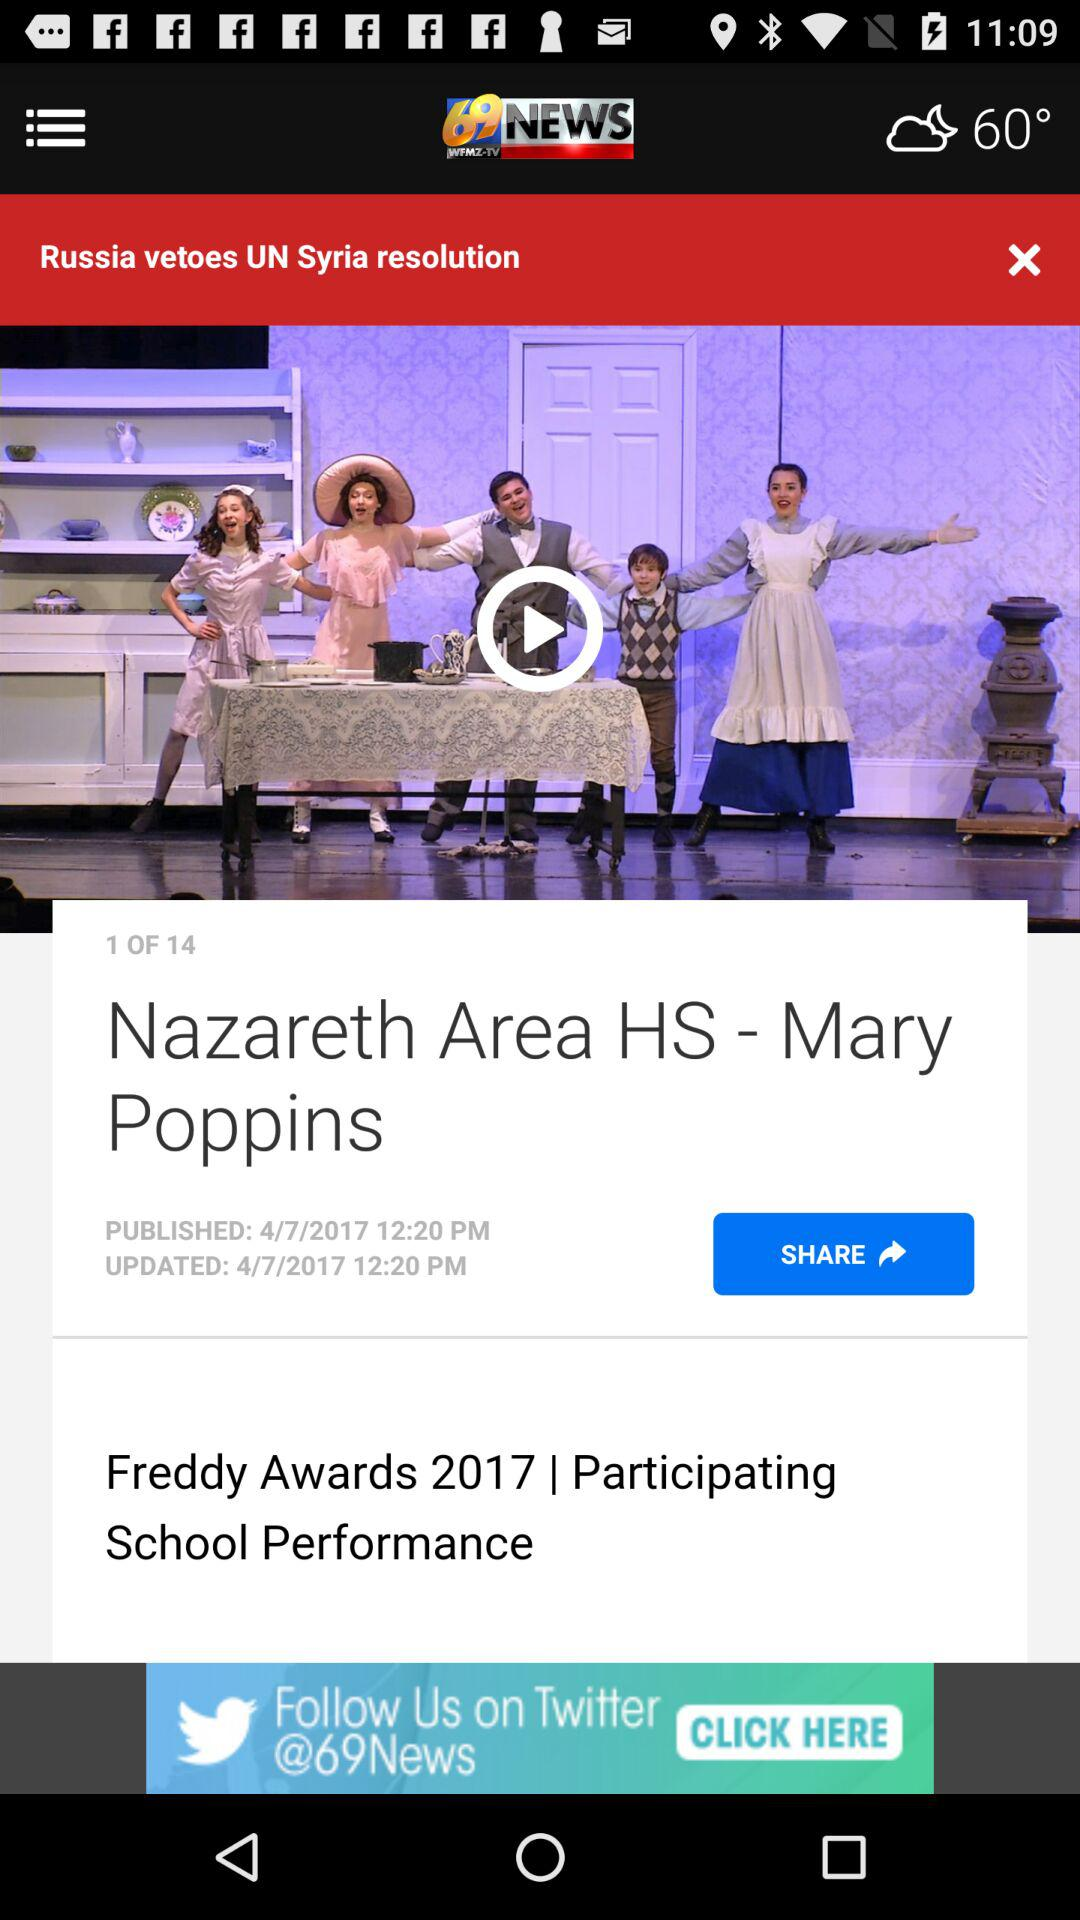What is the total number of pages? The total number of pages is 14. 